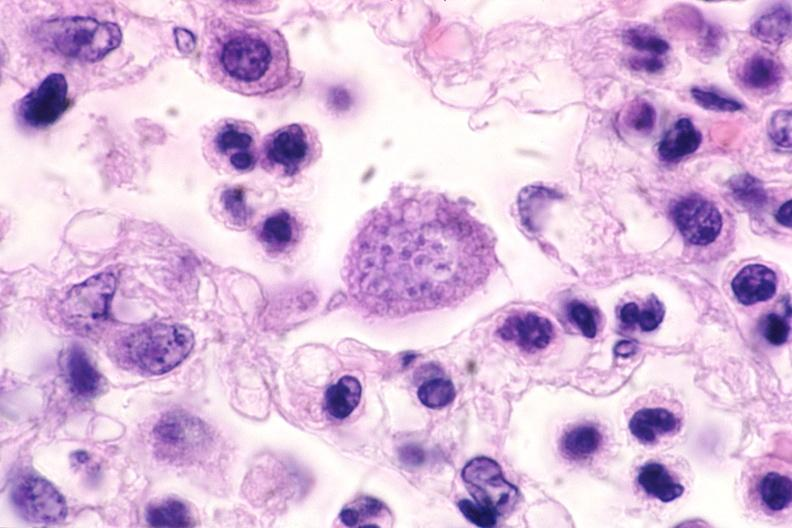does pituitectomy show touch impression from brain, toxoplasma cyst?
Answer the question using a single word or phrase. No 